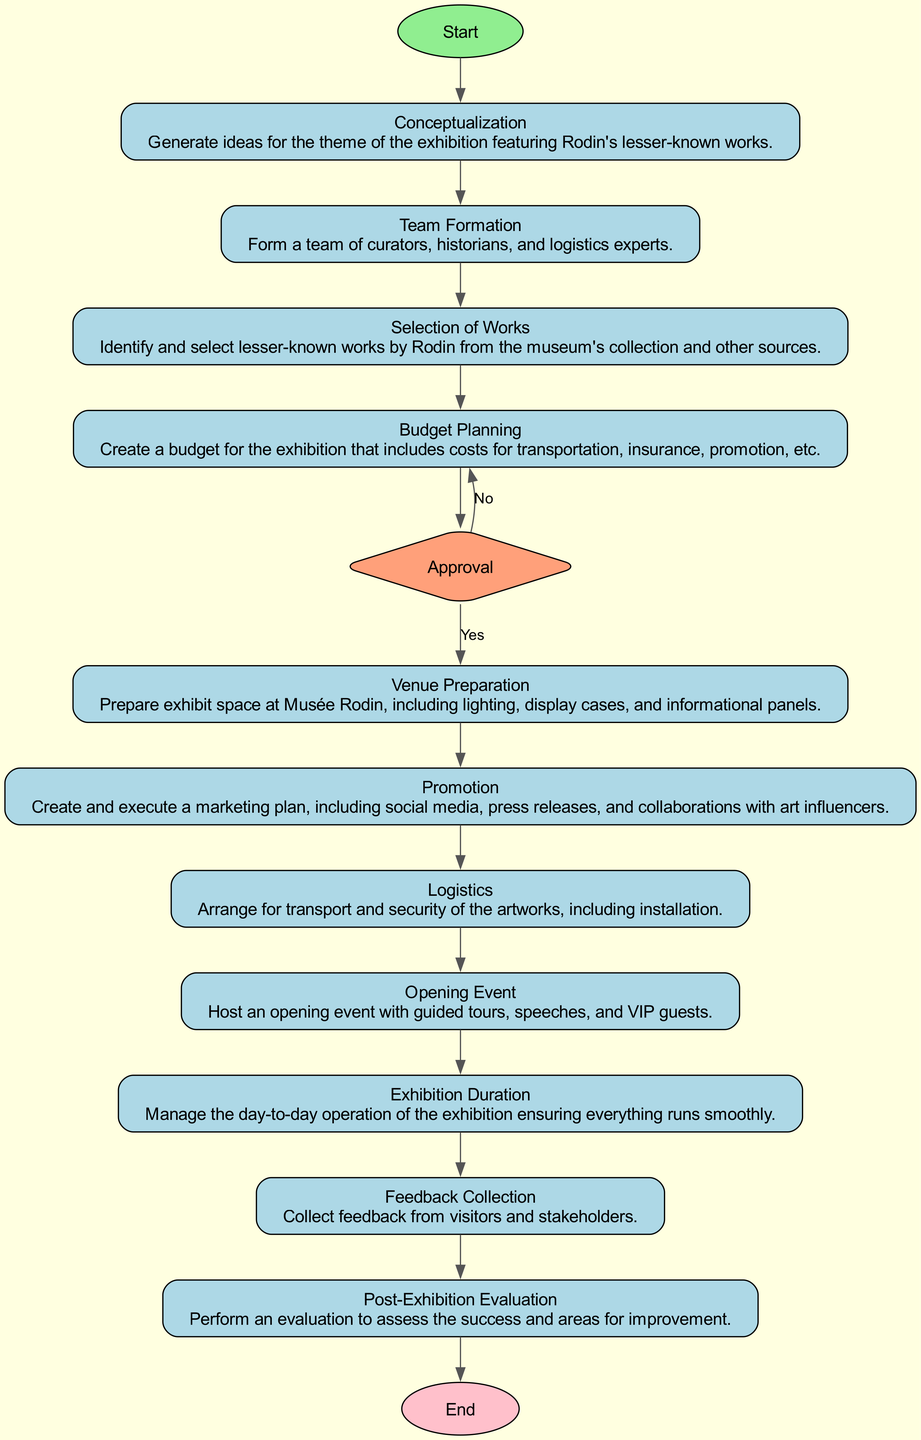What is the first process in the flowchart? The first process after the start node is "Conceptualization." This is evident from the direct edge that connects the "Start" node to the "Conceptualization" node.
Answer: Conceptualization How many processes are there in total? By counting all the nodes of type 'process' in the diagram, we find there are 8 processes: "Conceptualization," "Team Formation," "Selection of Works," "Budget Planning," "Venue Preparation," "Promotion," "Logistics," and "Exhibition Duration."
Answer: 8 What decision point is present in the flowchart? The diagram contains one decision point labeled "Approval." This can be identified as the only diamond-shaped node, which reflects a conditional process in the overall flow.
Answer: Approval What happens if the approval is denied? If the "Approval" is denied, the flow returns to the "Budget Planning" process. This is shown by the edge labeled 'No' that leads back to the "Budget Planning" node from the "Approval" node, indicating a possible re-evaluation of the budget before proceeding.
Answer: Budget Planning What is the last process before the end of the flowchart? The last process encountered before reaching the "End" node is "Post-Exhibition Evaluation." The flow progresses through several nodes before arriving at this final process, which assesses the exhibition's outcomes.
Answer: Post-Exhibition Evaluation What is the relationship between "Promotion" and "Logistics"? The relationship is sequential; "Promotion" leads directly to "Logistics" as indicated by the edge connecting these two processes. This shows that after promoting the exhibition, the next step is to manage the logistics.
Answer: Sequential connection Which phase involves gathering visitor impressions? The phase that involves gathering visitor impressions is labeled "Feedback Collection." This node specifically indicates the collection of feedback, which is crucial for evaluating the exhibition's impact post-event.
Answer: Feedback Collection 